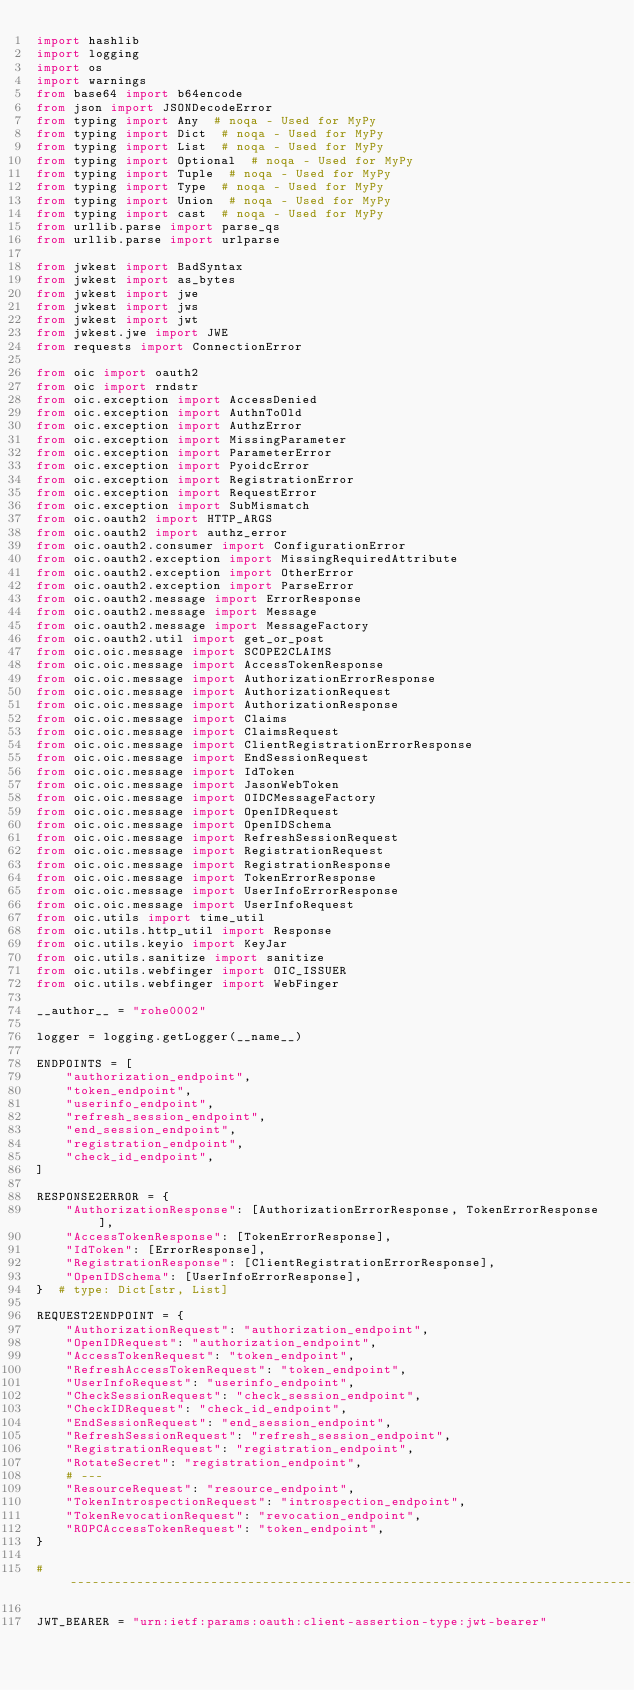<code> <loc_0><loc_0><loc_500><loc_500><_Python_>import hashlib
import logging
import os
import warnings
from base64 import b64encode
from json import JSONDecodeError
from typing import Any  # noqa - Used for MyPy
from typing import Dict  # noqa - Used for MyPy
from typing import List  # noqa - Used for MyPy
from typing import Optional  # noqa - Used for MyPy
from typing import Tuple  # noqa - Used for MyPy
from typing import Type  # noqa - Used for MyPy
from typing import Union  # noqa - Used for MyPy
from typing import cast  # noqa - Used for MyPy
from urllib.parse import parse_qs
from urllib.parse import urlparse

from jwkest import BadSyntax
from jwkest import as_bytes
from jwkest import jwe
from jwkest import jws
from jwkest import jwt
from jwkest.jwe import JWE
from requests import ConnectionError

from oic import oauth2
from oic import rndstr
from oic.exception import AccessDenied
from oic.exception import AuthnToOld
from oic.exception import AuthzError
from oic.exception import MissingParameter
from oic.exception import ParameterError
from oic.exception import PyoidcError
from oic.exception import RegistrationError
from oic.exception import RequestError
from oic.exception import SubMismatch
from oic.oauth2 import HTTP_ARGS
from oic.oauth2 import authz_error
from oic.oauth2.consumer import ConfigurationError
from oic.oauth2.exception import MissingRequiredAttribute
from oic.oauth2.exception import OtherError
from oic.oauth2.exception import ParseError
from oic.oauth2.message import ErrorResponse
from oic.oauth2.message import Message
from oic.oauth2.message import MessageFactory
from oic.oauth2.util import get_or_post
from oic.oic.message import SCOPE2CLAIMS
from oic.oic.message import AccessTokenResponse
from oic.oic.message import AuthorizationErrorResponse
from oic.oic.message import AuthorizationRequest
from oic.oic.message import AuthorizationResponse
from oic.oic.message import Claims
from oic.oic.message import ClaimsRequest
from oic.oic.message import ClientRegistrationErrorResponse
from oic.oic.message import EndSessionRequest
from oic.oic.message import IdToken
from oic.oic.message import JasonWebToken
from oic.oic.message import OIDCMessageFactory
from oic.oic.message import OpenIDRequest
from oic.oic.message import OpenIDSchema
from oic.oic.message import RefreshSessionRequest
from oic.oic.message import RegistrationRequest
from oic.oic.message import RegistrationResponse
from oic.oic.message import TokenErrorResponse
from oic.oic.message import UserInfoErrorResponse
from oic.oic.message import UserInfoRequest
from oic.utils import time_util
from oic.utils.http_util import Response
from oic.utils.keyio import KeyJar
from oic.utils.sanitize import sanitize
from oic.utils.webfinger import OIC_ISSUER
from oic.utils.webfinger import WebFinger

__author__ = "rohe0002"

logger = logging.getLogger(__name__)

ENDPOINTS = [
    "authorization_endpoint",
    "token_endpoint",
    "userinfo_endpoint",
    "refresh_session_endpoint",
    "end_session_endpoint",
    "registration_endpoint",
    "check_id_endpoint",
]

RESPONSE2ERROR = {
    "AuthorizationResponse": [AuthorizationErrorResponse, TokenErrorResponse],
    "AccessTokenResponse": [TokenErrorResponse],
    "IdToken": [ErrorResponse],
    "RegistrationResponse": [ClientRegistrationErrorResponse],
    "OpenIDSchema": [UserInfoErrorResponse],
}  # type: Dict[str, List]

REQUEST2ENDPOINT = {
    "AuthorizationRequest": "authorization_endpoint",
    "OpenIDRequest": "authorization_endpoint",
    "AccessTokenRequest": "token_endpoint",
    "RefreshAccessTokenRequest": "token_endpoint",
    "UserInfoRequest": "userinfo_endpoint",
    "CheckSessionRequest": "check_session_endpoint",
    "CheckIDRequest": "check_id_endpoint",
    "EndSessionRequest": "end_session_endpoint",
    "RefreshSessionRequest": "refresh_session_endpoint",
    "RegistrationRequest": "registration_endpoint",
    "RotateSecret": "registration_endpoint",
    # ---
    "ResourceRequest": "resource_endpoint",
    "TokenIntrospectionRequest": "introspection_endpoint",
    "TokenRevocationRequest": "revocation_endpoint",
    "ROPCAccessTokenRequest": "token_endpoint",
}

# -----------------------------------------------------------------------------

JWT_BEARER = "urn:ietf:params:oauth:client-assertion-type:jwt-bearer"</code> 